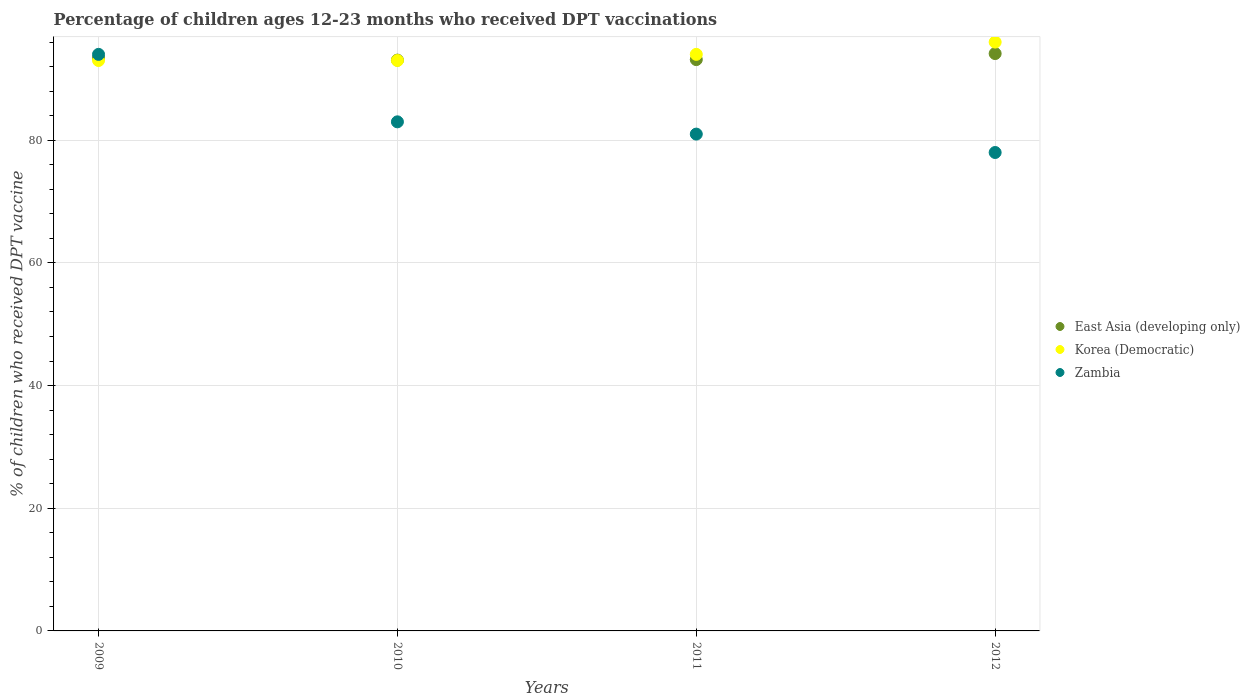What is the percentage of children who received DPT vaccination in Korea (Democratic) in 2011?
Your answer should be very brief. 94. Across all years, what is the maximum percentage of children who received DPT vaccination in Korea (Democratic)?
Your response must be concise. 96. Across all years, what is the minimum percentage of children who received DPT vaccination in Korea (Democratic)?
Keep it short and to the point. 93. In which year was the percentage of children who received DPT vaccination in East Asia (developing only) maximum?
Provide a short and direct response. 2012. In which year was the percentage of children who received DPT vaccination in Korea (Democratic) minimum?
Provide a succinct answer. 2009. What is the total percentage of children who received DPT vaccination in Korea (Democratic) in the graph?
Give a very brief answer. 376. What is the difference between the percentage of children who received DPT vaccination in East Asia (developing only) in 2010 and that in 2012?
Offer a very short reply. -1.07. What is the difference between the percentage of children who received DPT vaccination in Zambia in 2011 and the percentage of children who received DPT vaccination in East Asia (developing only) in 2012?
Your answer should be compact. -13.13. What is the average percentage of children who received DPT vaccination in Korea (Democratic) per year?
Provide a short and direct response. 94. In the year 2009, what is the difference between the percentage of children who received DPT vaccination in East Asia (developing only) and percentage of children who received DPT vaccination in Zambia?
Offer a terse response. -0.59. In how many years, is the percentage of children who received DPT vaccination in Zambia greater than 36 %?
Your response must be concise. 4. What is the ratio of the percentage of children who received DPT vaccination in East Asia (developing only) in 2010 to that in 2011?
Offer a terse response. 1. Is the percentage of children who received DPT vaccination in East Asia (developing only) in 2009 less than that in 2012?
Your response must be concise. Yes. What is the difference between the highest and the second highest percentage of children who received DPT vaccination in East Asia (developing only)?
Offer a terse response. 0.72. What is the difference between the highest and the lowest percentage of children who received DPT vaccination in Korea (Democratic)?
Your answer should be very brief. 3. In how many years, is the percentage of children who received DPT vaccination in Korea (Democratic) greater than the average percentage of children who received DPT vaccination in Korea (Democratic) taken over all years?
Your answer should be compact. 1. Is it the case that in every year, the sum of the percentage of children who received DPT vaccination in Zambia and percentage of children who received DPT vaccination in East Asia (developing only)  is greater than the percentage of children who received DPT vaccination in Korea (Democratic)?
Make the answer very short. Yes. Does the percentage of children who received DPT vaccination in East Asia (developing only) monotonically increase over the years?
Keep it short and to the point. No. Is the percentage of children who received DPT vaccination in Zambia strictly less than the percentage of children who received DPT vaccination in East Asia (developing only) over the years?
Provide a succinct answer. No. What is the difference between two consecutive major ticks on the Y-axis?
Provide a short and direct response. 20. Are the values on the major ticks of Y-axis written in scientific E-notation?
Provide a succinct answer. No. Does the graph contain grids?
Your answer should be very brief. Yes. Where does the legend appear in the graph?
Your response must be concise. Center right. How many legend labels are there?
Give a very brief answer. 3. How are the legend labels stacked?
Your response must be concise. Vertical. What is the title of the graph?
Provide a short and direct response. Percentage of children ages 12-23 months who received DPT vaccinations. Does "Colombia" appear as one of the legend labels in the graph?
Make the answer very short. No. What is the label or title of the X-axis?
Keep it short and to the point. Years. What is the label or title of the Y-axis?
Ensure brevity in your answer.  % of children who received DPT vaccine. What is the % of children who received DPT vaccine of East Asia (developing only) in 2009?
Offer a terse response. 93.41. What is the % of children who received DPT vaccine of Korea (Democratic) in 2009?
Provide a succinct answer. 93. What is the % of children who received DPT vaccine in Zambia in 2009?
Provide a short and direct response. 94. What is the % of children who received DPT vaccine in East Asia (developing only) in 2010?
Keep it short and to the point. 93.06. What is the % of children who received DPT vaccine of Korea (Democratic) in 2010?
Ensure brevity in your answer.  93. What is the % of children who received DPT vaccine of East Asia (developing only) in 2011?
Offer a terse response. 93.15. What is the % of children who received DPT vaccine in Korea (Democratic) in 2011?
Make the answer very short. 94. What is the % of children who received DPT vaccine in Zambia in 2011?
Provide a succinct answer. 81. What is the % of children who received DPT vaccine in East Asia (developing only) in 2012?
Offer a very short reply. 94.13. What is the % of children who received DPT vaccine in Korea (Democratic) in 2012?
Your answer should be compact. 96. What is the % of children who received DPT vaccine of Zambia in 2012?
Keep it short and to the point. 78. Across all years, what is the maximum % of children who received DPT vaccine of East Asia (developing only)?
Offer a terse response. 94.13. Across all years, what is the maximum % of children who received DPT vaccine in Korea (Democratic)?
Ensure brevity in your answer.  96. Across all years, what is the maximum % of children who received DPT vaccine of Zambia?
Your answer should be compact. 94. Across all years, what is the minimum % of children who received DPT vaccine in East Asia (developing only)?
Your response must be concise. 93.06. Across all years, what is the minimum % of children who received DPT vaccine of Korea (Democratic)?
Provide a succinct answer. 93. What is the total % of children who received DPT vaccine in East Asia (developing only) in the graph?
Offer a very short reply. 373.75. What is the total % of children who received DPT vaccine in Korea (Democratic) in the graph?
Ensure brevity in your answer.  376. What is the total % of children who received DPT vaccine of Zambia in the graph?
Keep it short and to the point. 336. What is the difference between the % of children who received DPT vaccine in East Asia (developing only) in 2009 and that in 2010?
Make the answer very short. 0.35. What is the difference between the % of children who received DPT vaccine of Korea (Democratic) in 2009 and that in 2010?
Your answer should be very brief. 0. What is the difference between the % of children who received DPT vaccine in Zambia in 2009 and that in 2010?
Offer a very short reply. 11. What is the difference between the % of children who received DPT vaccine in East Asia (developing only) in 2009 and that in 2011?
Your response must be concise. 0.26. What is the difference between the % of children who received DPT vaccine of East Asia (developing only) in 2009 and that in 2012?
Keep it short and to the point. -0.72. What is the difference between the % of children who received DPT vaccine of Zambia in 2009 and that in 2012?
Your response must be concise. 16. What is the difference between the % of children who received DPT vaccine in East Asia (developing only) in 2010 and that in 2011?
Your response must be concise. -0.08. What is the difference between the % of children who received DPT vaccine in Korea (Democratic) in 2010 and that in 2011?
Provide a short and direct response. -1. What is the difference between the % of children who received DPT vaccine in East Asia (developing only) in 2010 and that in 2012?
Your answer should be very brief. -1.07. What is the difference between the % of children who received DPT vaccine of Korea (Democratic) in 2010 and that in 2012?
Your answer should be very brief. -3. What is the difference between the % of children who received DPT vaccine in Zambia in 2010 and that in 2012?
Offer a terse response. 5. What is the difference between the % of children who received DPT vaccine in East Asia (developing only) in 2011 and that in 2012?
Keep it short and to the point. -0.98. What is the difference between the % of children who received DPT vaccine in Korea (Democratic) in 2011 and that in 2012?
Offer a terse response. -2. What is the difference between the % of children who received DPT vaccine of East Asia (developing only) in 2009 and the % of children who received DPT vaccine of Korea (Democratic) in 2010?
Give a very brief answer. 0.41. What is the difference between the % of children who received DPT vaccine of East Asia (developing only) in 2009 and the % of children who received DPT vaccine of Zambia in 2010?
Provide a succinct answer. 10.41. What is the difference between the % of children who received DPT vaccine of East Asia (developing only) in 2009 and the % of children who received DPT vaccine of Korea (Democratic) in 2011?
Your answer should be very brief. -0.59. What is the difference between the % of children who received DPT vaccine of East Asia (developing only) in 2009 and the % of children who received DPT vaccine of Zambia in 2011?
Offer a very short reply. 12.41. What is the difference between the % of children who received DPT vaccine in Korea (Democratic) in 2009 and the % of children who received DPT vaccine in Zambia in 2011?
Your answer should be compact. 12. What is the difference between the % of children who received DPT vaccine of East Asia (developing only) in 2009 and the % of children who received DPT vaccine of Korea (Democratic) in 2012?
Keep it short and to the point. -2.59. What is the difference between the % of children who received DPT vaccine of East Asia (developing only) in 2009 and the % of children who received DPT vaccine of Zambia in 2012?
Your response must be concise. 15.41. What is the difference between the % of children who received DPT vaccine of East Asia (developing only) in 2010 and the % of children who received DPT vaccine of Korea (Democratic) in 2011?
Provide a short and direct response. -0.94. What is the difference between the % of children who received DPT vaccine in East Asia (developing only) in 2010 and the % of children who received DPT vaccine in Zambia in 2011?
Provide a succinct answer. 12.06. What is the difference between the % of children who received DPT vaccine in East Asia (developing only) in 2010 and the % of children who received DPT vaccine in Korea (Democratic) in 2012?
Provide a short and direct response. -2.94. What is the difference between the % of children who received DPT vaccine in East Asia (developing only) in 2010 and the % of children who received DPT vaccine in Zambia in 2012?
Offer a terse response. 15.06. What is the difference between the % of children who received DPT vaccine in East Asia (developing only) in 2011 and the % of children who received DPT vaccine in Korea (Democratic) in 2012?
Make the answer very short. -2.85. What is the difference between the % of children who received DPT vaccine of East Asia (developing only) in 2011 and the % of children who received DPT vaccine of Zambia in 2012?
Give a very brief answer. 15.15. What is the average % of children who received DPT vaccine of East Asia (developing only) per year?
Provide a short and direct response. 93.44. What is the average % of children who received DPT vaccine in Korea (Democratic) per year?
Your answer should be very brief. 94. What is the average % of children who received DPT vaccine of Zambia per year?
Ensure brevity in your answer.  84. In the year 2009, what is the difference between the % of children who received DPT vaccine in East Asia (developing only) and % of children who received DPT vaccine in Korea (Democratic)?
Provide a succinct answer. 0.41. In the year 2009, what is the difference between the % of children who received DPT vaccine of East Asia (developing only) and % of children who received DPT vaccine of Zambia?
Keep it short and to the point. -0.59. In the year 2010, what is the difference between the % of children who received DPT vaccine of East Asia (developing only) and % of children who received DPT vaccine of Korea (Democratic)?
Provide a succinct answer. 0.06. In the year 2010, what is the difference between the % of children who received DPT vaccine in East Asia (developing only) and % of children who received DPT vaccine in Zambia?
Make the answer very short. 10.06. In the year 2011, what is the difference between the % of children who received DPT vaccine in East Asia (developing only) and % of children who received DPT vaccine in Korea (Democratic)?
Ensure brevity in your answer.  -0.85. In the year 2011, what is the difference between the % of children who received DPT vaccine in East Asia (developing only) and % of children who received DPT vaccine in Zambia?
Your answer should be compact. 12.15. In the year 2012, what is the difference between the % of children who received DPT vaccine of East Asia (developing only) and % of children who received DPT vaccine of Korea (Democratic)?
Your answer should be very brief. -1.87. In the year 2012, what is the difference between the % of children who received DPT vaccine of East Asia (developing only) and % of children who received DPT vaccine of Zambia?
Provide a short and direct response. 16.13. In the year 2012, what is the difference between the % of children who received DPT vaccine in Korea (Democratic) and % of children who received DPT vaccine in Zambia?
Offer a terse response. 18. What is the ratio of the % of children who received DPT vaccine in Zambia in 2009 to that in 2010?
Provide a short and direct response. 1.13. What is the ratio of the % of children who received DPT vaccine of East Asia (developing only) in 2009 to that in 2011?
Give a very brief answer. 1. What is the ratio of the % of children who received DPT vaccine of Zambia in 2009 to that in 2011?
Your answer should be compact. 1.16. What is the ratio of the % of children who received DPT vaccine of East Asia (developing only) in 2009 to that in 2012?
Provide a succinct answer. 0.99. What is the ratio of the % of children who received DPT vaccine in Korea (Democratic) in 2009 to that in 2012?
Offer a very short reply. 0.97. What is the ratio of the % of children who received DPT vaccine of Zambia in 2009 to that in 2012?
Give a very brief answer. 1.21. What is the ratio of the % of children who received DPT vaccine in Korea (Democratic) in 2010 to that in 2011?
Make the answer very short. 0.99. What is the ratio of the % of children who received DPT vaccine in Zambia in 2010 to that in 2011?
Ensure brevity in your answer.  1.02. What is the ratio of the % of children who received DPT vaccine of East Asia (developing only) in 2010 to that in 2012?
Your response must be concise. 0.99. What is the ratio of the % of children who received DPT vaccine of Korea (Democratic) in 2010 to that in 2012?
Keep it short and to the point. 0.97. What is the ratio of the % of children who received DPT vaccine of Zambia in 2010 to that in 2012?
Provide a succinct answer. 1.06. What is the ratio of the % of children who received DPT vaccine in Korea (Democratic) in 2011 to that in 2012?
Keep it short and to the point. 0.98. What is the ratio of the % of children who received DPT vaccine of Zambia in 2011 to that in 2012?
Your answer should be very brief. 1.04. What is the difference between the highest and the second highest % of children who received DPT vaccine of East Asia (developing only)?
Make the answer very short. 0.72. What is the difference between the highest and the lowest % of children who received DPT vaccine in East Asia (developing only)?
Offer a terse response. 1.07. What is the difference between the highest and the lowest % of children who received DPT vaccine of Korea (Democratic)?
Ensure brevity in your answer.  3. 